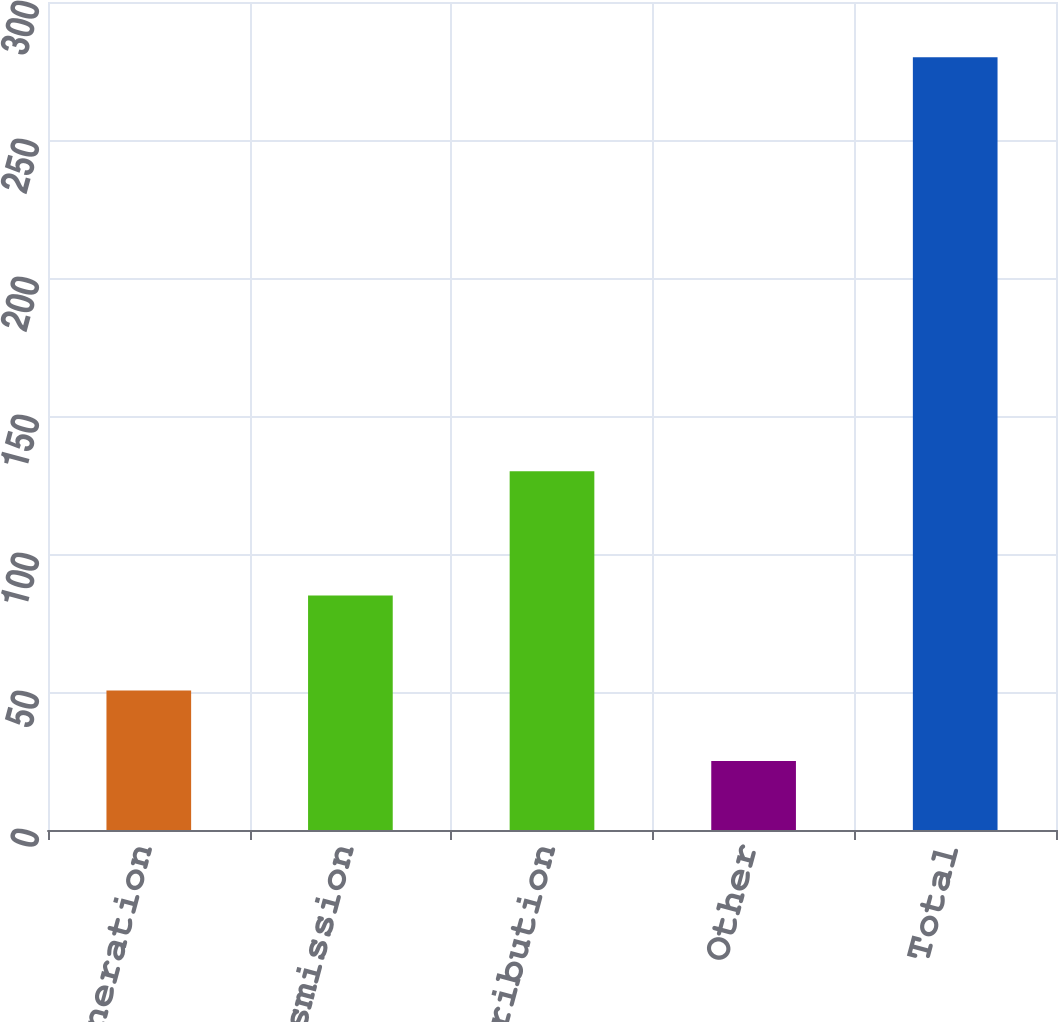<chart> <loc_0><loc_0><loc_500><loc_500><bar_chart><fcel>Generation<fcel>Transmission<fcel>Distribution<fcel>Other<fcel>Total<nl><fcel>50.5<fcel>85<fcel>130<fcel>25<fcel>280<nl></chart> 